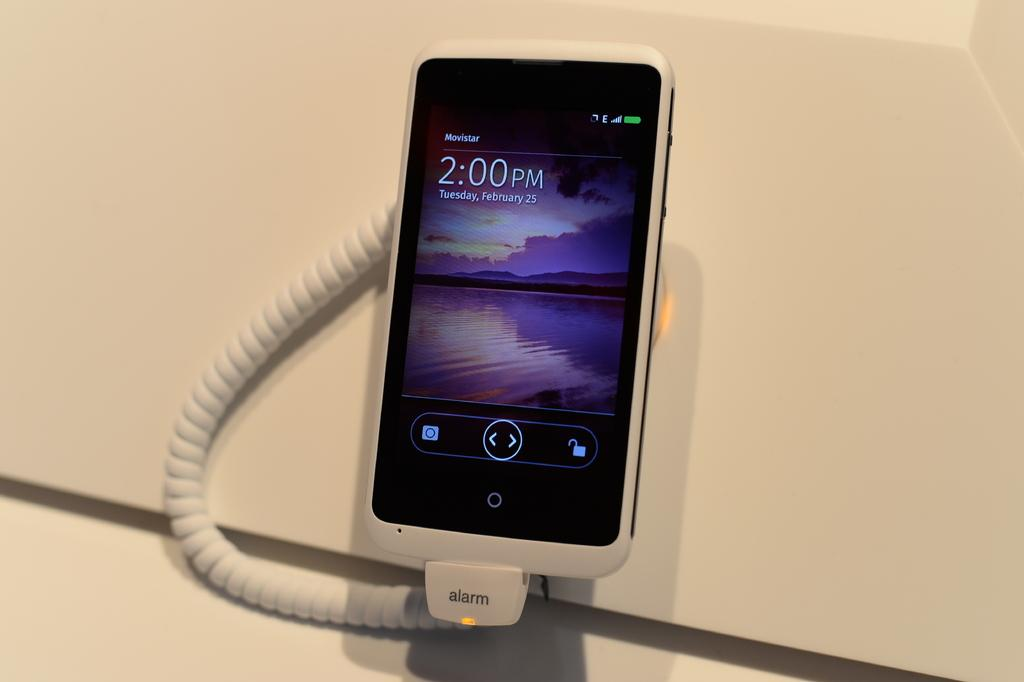What is the main object in the center of the image? There is a phone in the center of the image. Can you describe any additional features near the phone? There is a wire near the phone. What color is the substance visible in the background of the image? There is a white color substance in the background of the image. How many jellyfish can be seen swimming in the background of the image? There are no jellyfish present in the image; it features a phone and a wire. What direction is the phone facing in the image? The image does not provide information about the direction the phone is facing. 